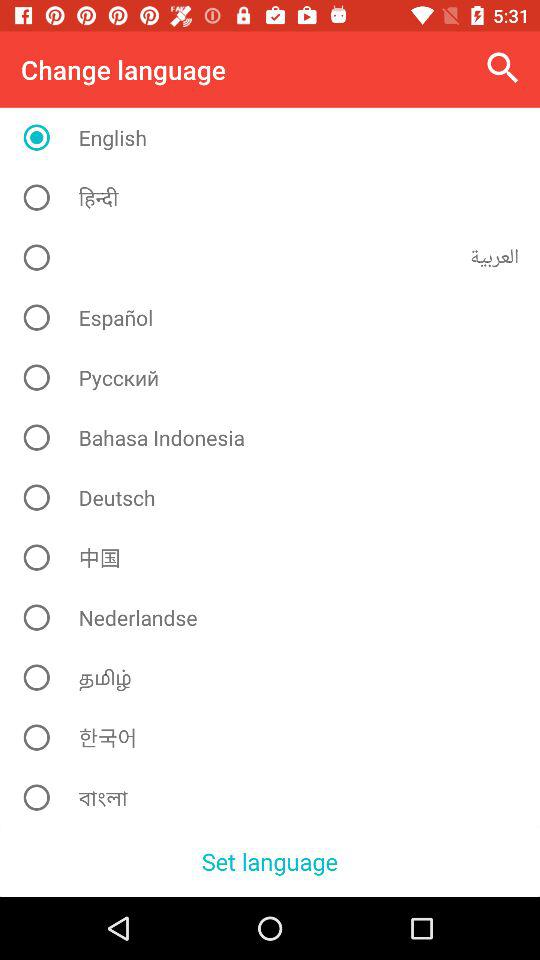What is the name of the application?
When the provided information is insufficient, respond with <no answer>. <no answer> 